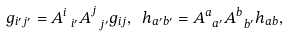<formula> <loc_0><loc_0><loc_500><loc_500>g _ { i ^ { \prime } j ^ { \prime } } = A _ { \ i ^ { \prime } } ^ { i } A _ { \ j ^ { \prime } } ^ { j } g _ { i j } , \ h _ { a ^ { \prime } b ^ { \prime } } = A _ { \ a ^ { \prime } } ^ { a } A _ { \ b ^ { \prime } } ^ { b } h _ { a b } ,</formula> 